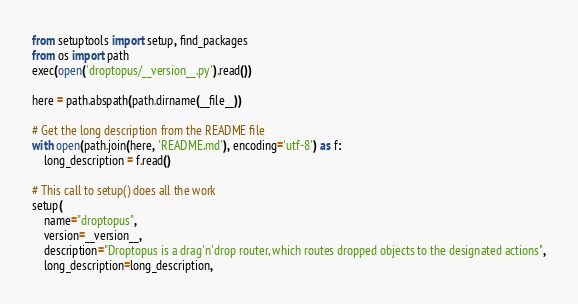<code> <loc_0><loc_0><loc_500><loc_500><_Python_>from setuptools import setup, find_packages
from os import path
exec(open('droptopus/__version__.py').read())

here = path.abspath(path.dirname(__file__))

# Get the long description from the README file
with open(path.join(here, 'README.md'), encoding='utf-8') as f:
    long_description = f.read()

# This call to setup() does all the work
setup(
    name="droptopus",
    version=__version__,
    description="Droptopus is a drag'n'drop router, which routes dropped objects to the designated actions",
    long_description=long_description,</code> 